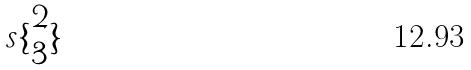<formula> <loc_0><loc_0><loc_500><loc_500>s \{ \begin{matrix} 2 \\ 3 \end{matrix} \}</formula> 